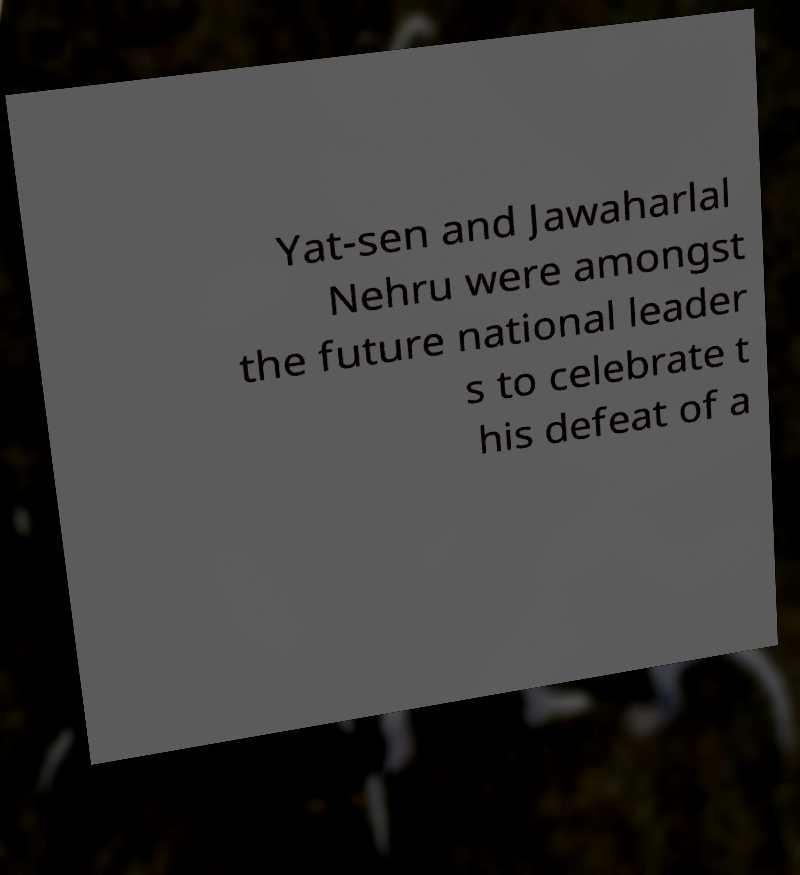What messages or text are displayed in this image? I need them in a readable, typed format. Yat-sen and Jawaharlal Nehru were amongst the future national leader s to celebrate t his defeat of a 